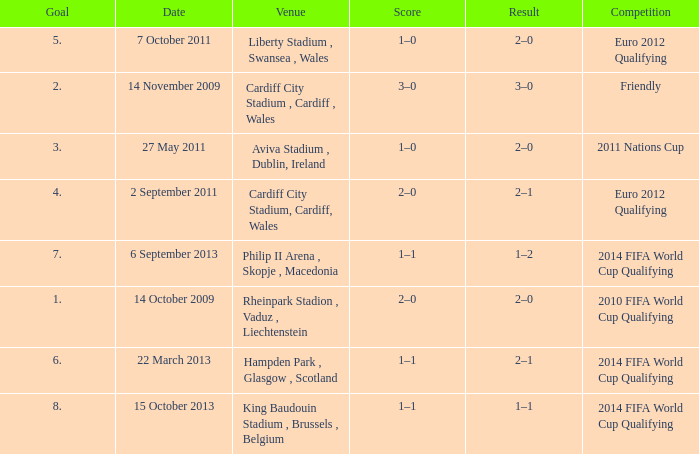What is the Venue for Goal number 1? Rheinpark Stadion , Vaduz , Liechtenstein. 